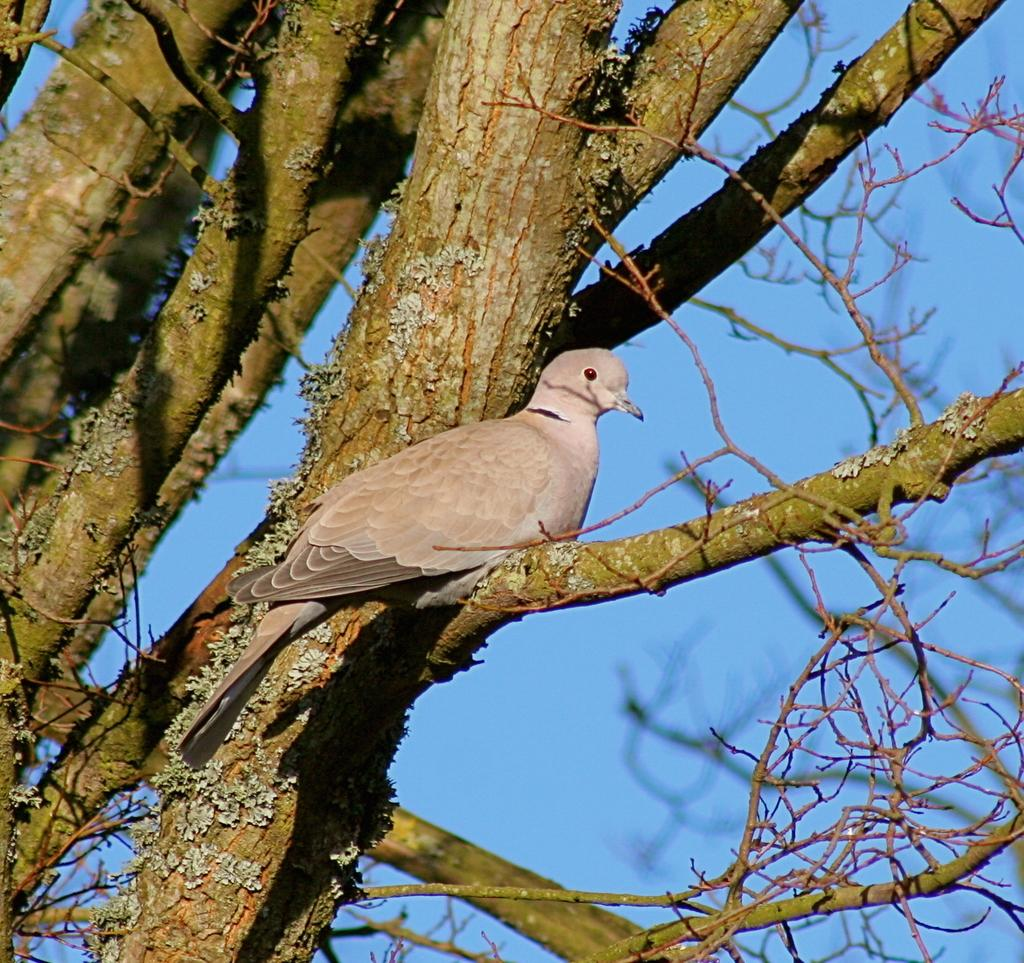What type of animal can be seen in the image? There is a bird in the image. Where is the bird located in the image? The bird is sitting on the branch of a tree. What part of the natural environment is visible in the image? The sky is visible in the image. What type of magic does the bird use to fly in the image? The bird does not use magic to fly in the image; birds naturally have the ability to fly. How does the bird lift the tree branch in the image? The bird does not lift the tree branch in the image; it is simply sitting on the branch. 